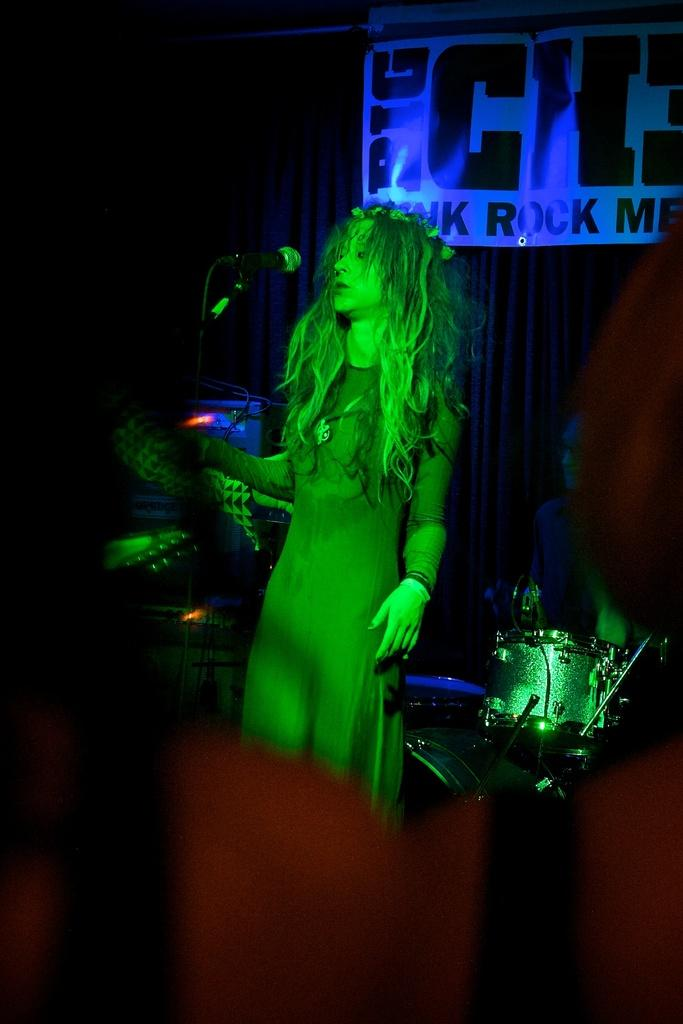What is the person standing in the image doing? The person standing in the image is holding a mic. What is the sitting person in the image doing? The sitting person in the image is near a musical instrument. What can be seen in the background of the image? There is a curtain and a poster with text in the background of the image. What type of caption is written on the poster in the image? There is no caption present on the poster in the image; it only contains text. What is the copper content of the musical instrument in the image? There is no mention of copper content in the image, as it focuses on the people and their actions, as well as the background elements. 